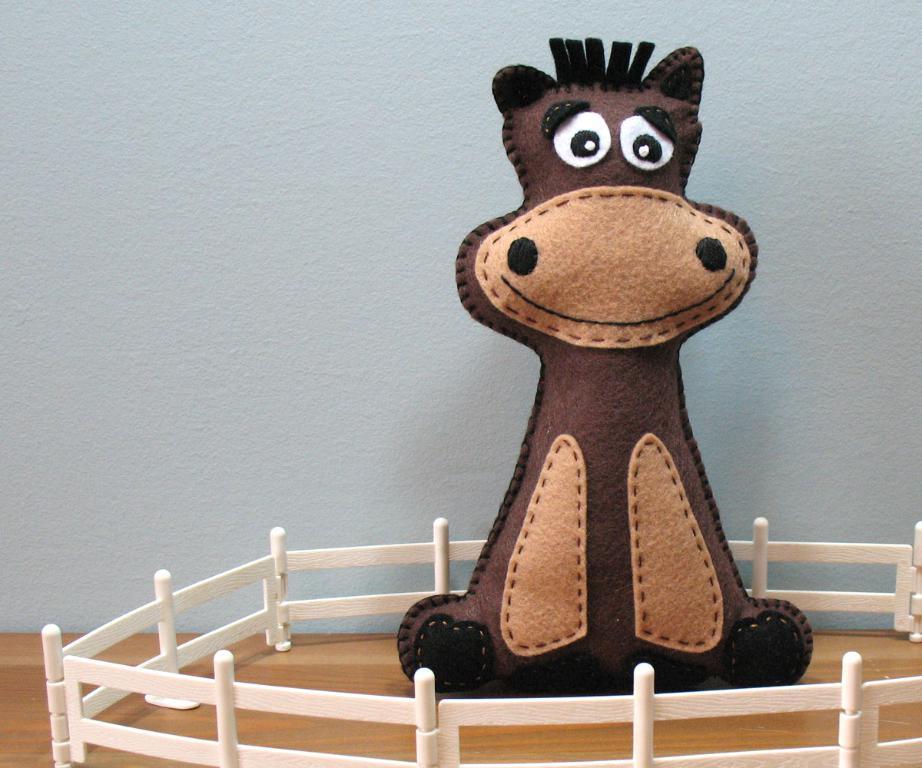Describe this image in one or two sentences. In this image I can see the cream and brown colored surface on which I can see the white colored railing and a brown, black and white colored toy in the middle of the railing. In the background I can see the white colored wall. 